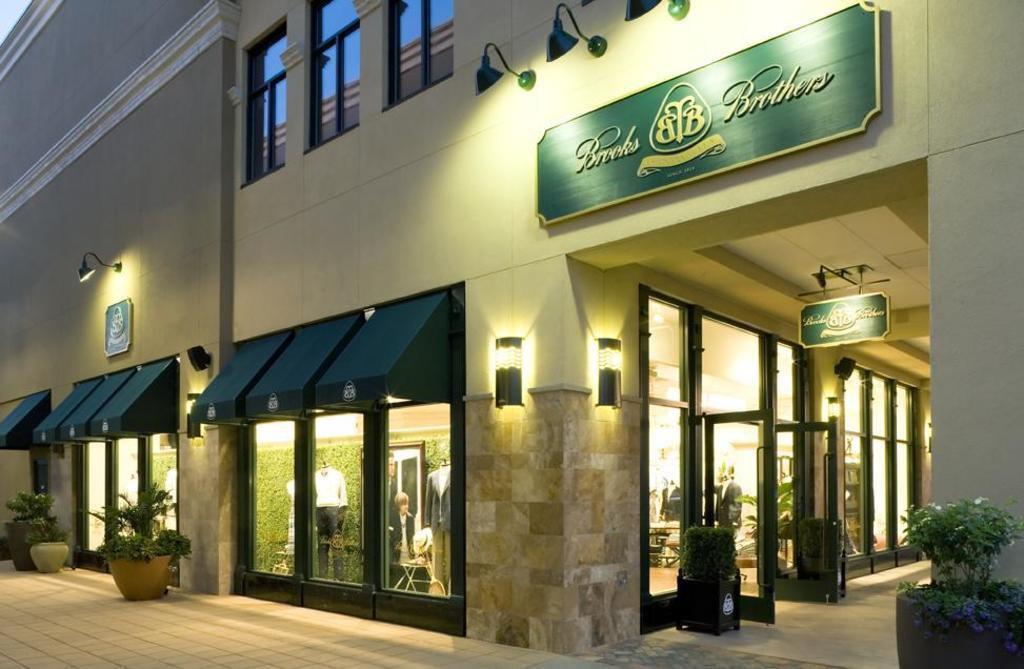What type of structure can be seen in the image? There is a building in the image. What is one feature of the building? There is a wall in the image. What can be seen on the wall? There are windows in the image. What material is used for the windows? There is glass in the image. What can be observed through the glass? People are visible through the glass, and the sky is visible through the glass windows. What else is present in the image? There are boards and plants in the image. What type of winter clothing can be seen on the people in the image? There is no mention of winter clothing in the image. 